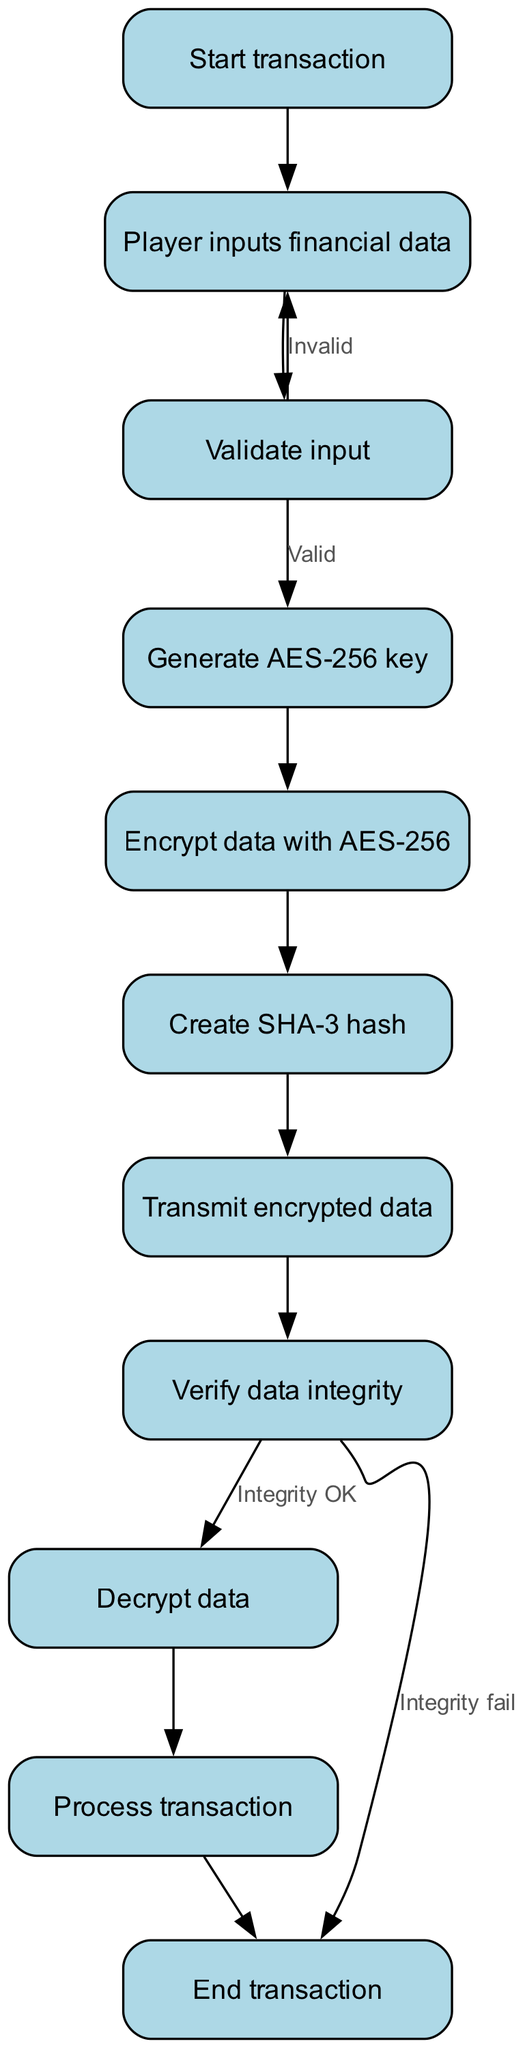What is the first step in the transaction process? The first step that starts the process is "Start transaction." This node indicates the initial stage before any financial data is inputted.
Answer: Start transaction How many nodes are present in the flowchart? By counting the nodes including the start and end points, there are a total of 11 nodes represented in the flowchart.
Answer: 11 What action takes place if the input is invalid? If the input validation is marked as invalid, the flowchart directs the process back to the "Player inputs financial data" node, indicating a need to re-enter the data.
Answer: Input financial data Which encryption algorithm is used in the process? The flowchart specifies that AES-256 is the encryption algorithm utilized for securing the player's financial data during the transaction process.
Answer: AES-256 What is the outcome if the integrity of the data fails during verification? According to the flowchart, if the integrity of the data fails during the verification step, the process concludes by sending the flow directly to the "End transaction" node.
Answer: End transaction How does the flow progress after data is encrypted? Following the encryption of the data, the flow proceeds to create a SHA-3 hash, which is the next logical step in ensuring data integrity and security before transmission.
Answer: Create SHA-3 hash Which node processes the transaction after decryption? After the data is decrypted, the next step in the flow that takes place is "Process transaction," where the actual transaction operations are executed.
Answer: Process transaction What happens after the encrypted data is transmitted? Once the encrypted data is transmitted, the next step is to "Verify data integrity," ensuring the transmitted data was not altered or corrupted during transfer.
Answer: Verify data integrity What step comes after generating the AES-256 key? Following the generation of the AES-256 key, the flowchart indicates that the next action is to "Encrypt data with AES-256," where the financial data is secured with the generated key.
Answer: Encrypt data with AES-256 